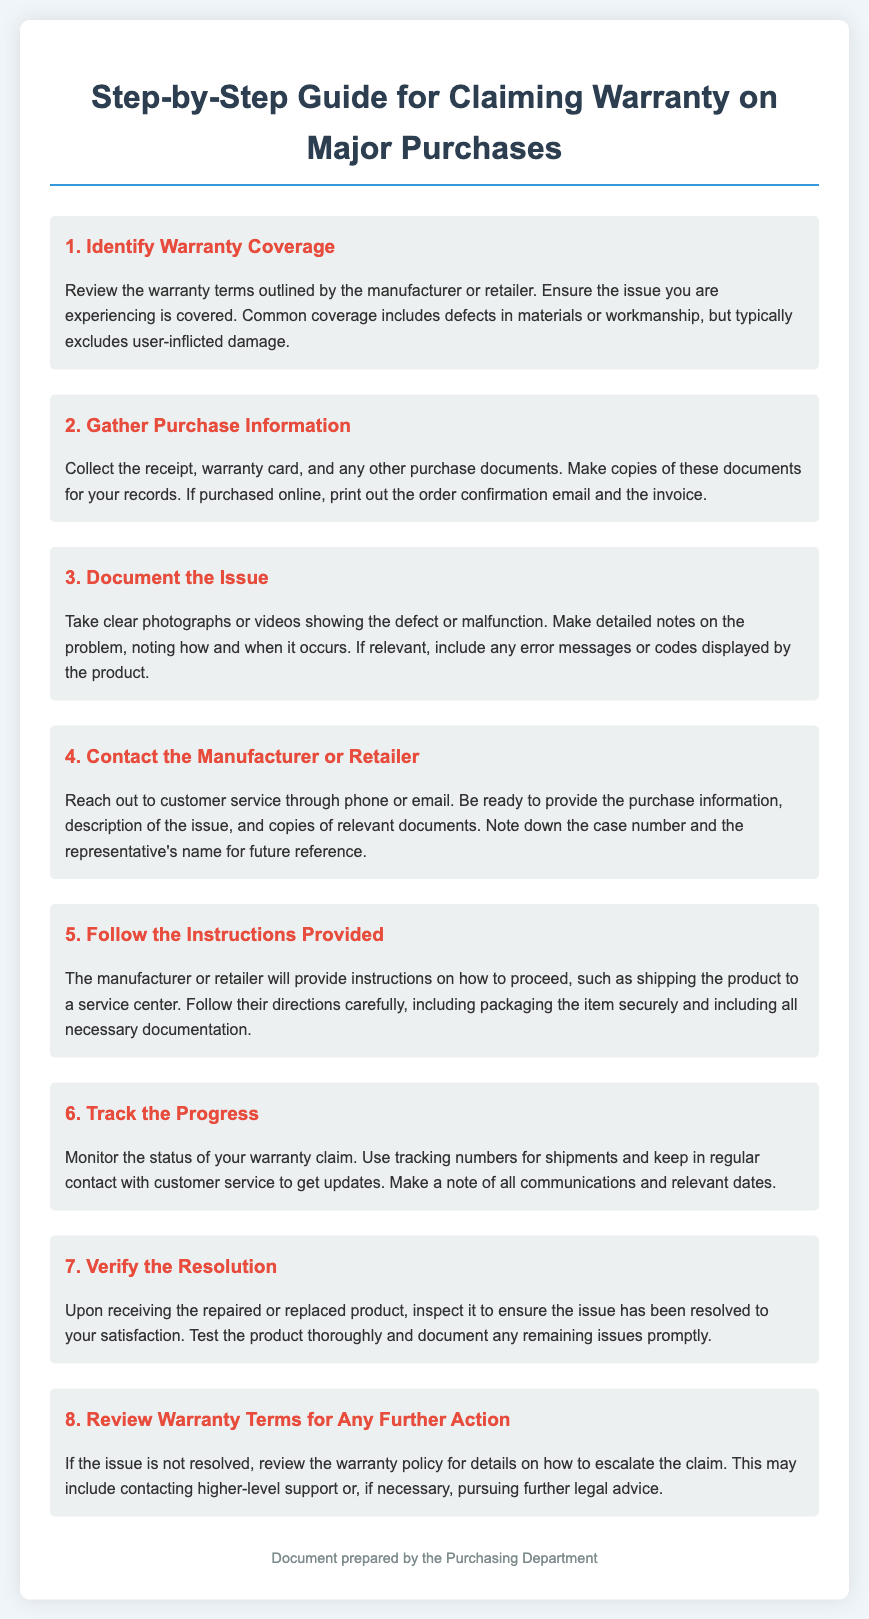What is the first step in claiming warranty? The first step is to identify warranty coverage by reviewing the warranty terms outlined by the manufacturer or retailer.
Answer: Identify Warranty Coverage What should you collect in the second step? You should collect the receipt, warranty card, and other purchase documents such as order confirmation emails.
Answer: Purchase Information What do you need to document in the third step? You need to take clear photographs or videos showing the defect or malfunction and make detailed notes on the problem.
Answer: Document the Issue What should you do after contacting customer service? You should follow the instructions provided by the manufacturer or retailer regarding the warranty claim process.
Answer: Follow the Instructions Provided How can you track the warranty claim's progress? You can track it by monitoring the status and using tracking numbers for shipments, keeping in contact with customer service.
Answer: Track the Progress What is suggested if the issue is not resolved? It is suggested to review the warranty policy for details on how to escalate the claim.
Answer: Review Warranty Terms for Any Further Action What materials should be included when packaging the item? You should include all necessary documentation when packaging the item for return.
Answer: Necessary Documentation How should you verify the resolution of your claim? Upon receiving the product, you should inspect it to ensure the issue has been resolved to your satisfaction.
Answer: Verify the Resolution 